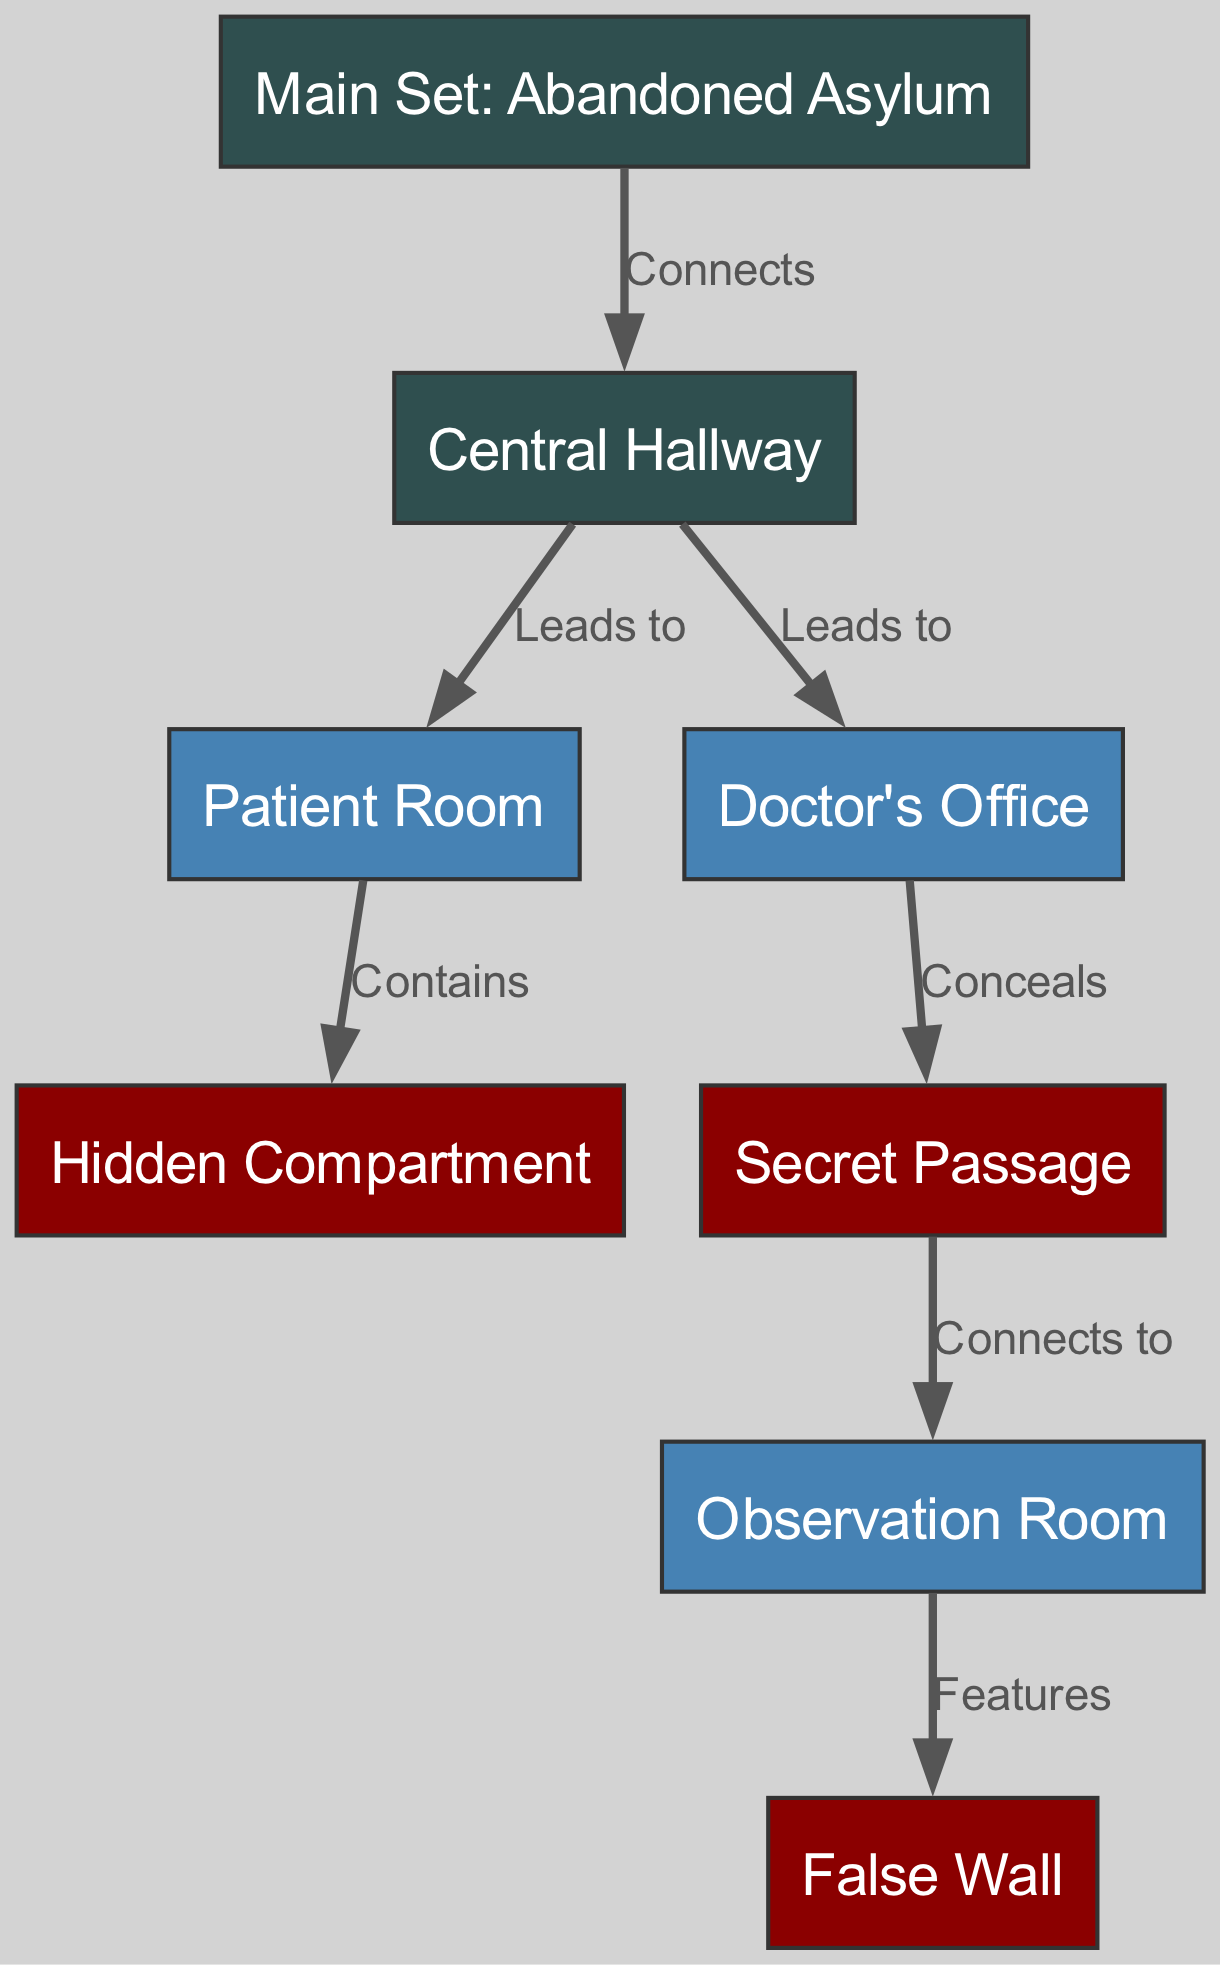What is the primary setting of the main set? The main set is labeled as "Abandoned Asylum," which indicates that it serves as the central location where the film's events unfold. This is derived from the node representing the main set in the diagram.
Answer: Abandoned Asylum How many rooms are connected to the central hallway? The central hallway connects to two specific rooms as indicated in the edges: the "Patient Room" and the "Doctor's Office." Thus, counting these connections gives the total number of rooms.
Answer: 2 Which room contains a hidden compartment? The "Patient Room" is directly connected to the "Hidden Compartment," as described in the edge relationship. Therefore, the answer comes from identifying the room that has this specific feature.
Answer: Patient Room What does the doctor's office conceal? According to the diagram, the "Doctor's Office" is connected to the "Secret Passage" with the label "Conceals," indicating that it hides or covers up this passage. Thus, the answer is directly from the edge's relationship.
Answer: Secret Passage What is the feature of the observation room? The diagram states that the "Observation Room" has a "False Wall," meaning that this room includes or exhibits this particular feature. The answer comes from the edge labeling connected to the observation room.
Answer: False Wall Which two locations are connected by the secret passage? The secret passage connects the "Doctor's Office" to the "Observation Room." To determine this, one can refer to the edge connection listed between those two nodes in the diagram.
Answer: Observation Room How many edges are depicted in the diagram? The diagram shows a total of six edges, which can be counted by reviewing the connections between the nodes as represented in the edges section. This counts all the relationships that connect different rooms and compartments.
Answer: 6 What role does the central hallway play in the set layout? The central hallway serves as a connecting structure that leads to both the "Patient Room" and the "Doctor's Office." Its pivotal position indicates it facilitates movement between these key areas in the set design.
Answer: Connects rooms What color represents the hidden compartments in the diagram? The hidden compartments and secretive elements are represented in dark red in the diagram, which is specified in the custom node styles for nodes that have "hidden" or "secret" in their identifiers.
Answer: Dark Red 